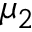<formula> <loc_0><loc_0><loc_500><loc_500>\mu _ { 2 }</formula> 